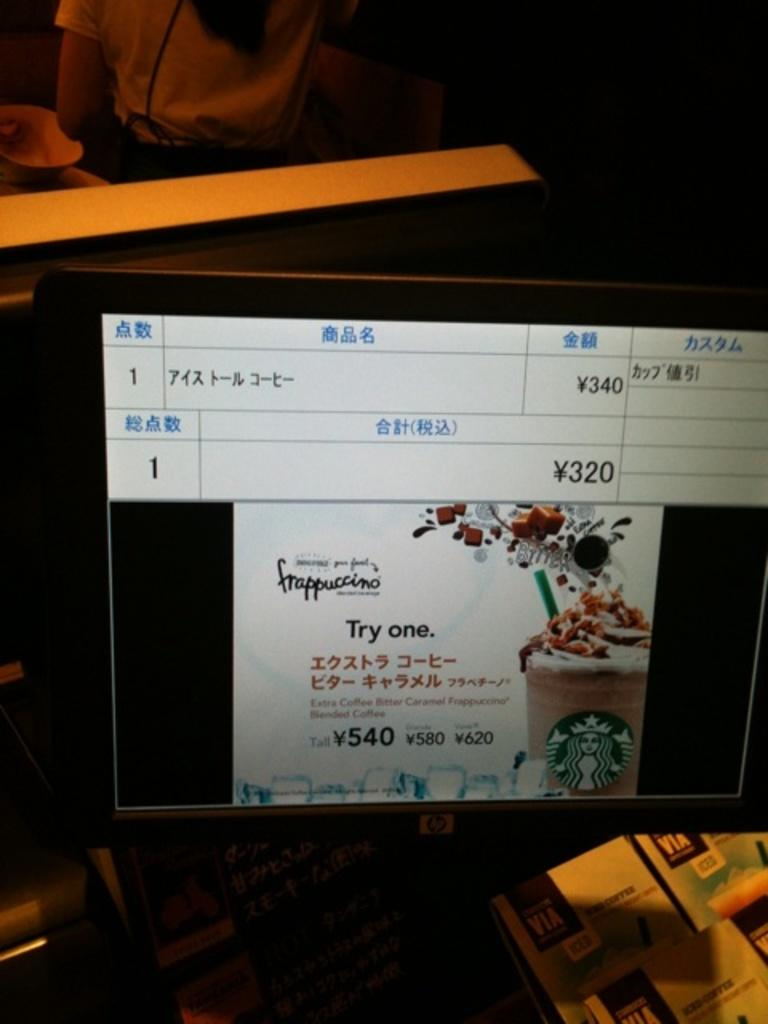Provide a one-sentence caption for the provided image. A monitor displays an advertisement for Starbucks Frappuccino. 